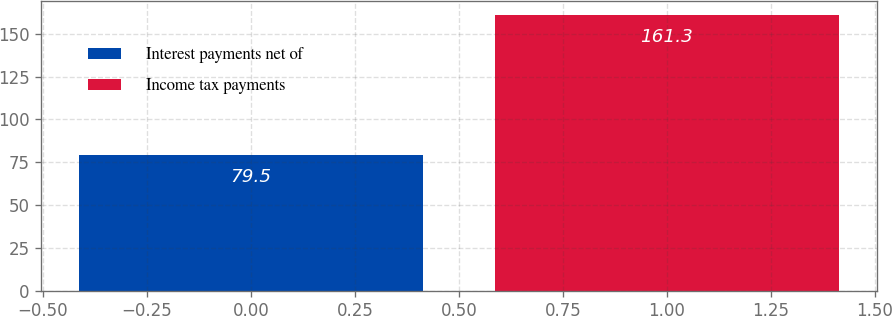Convert chart to OTSL. <chart><loc_0><loc_0><loc_500><loc_500><bar_chart><fcel>Interest payments net of<fcel>Income tax payments<nl><fcel>79.5<fcel>161.3<nl></chart> 